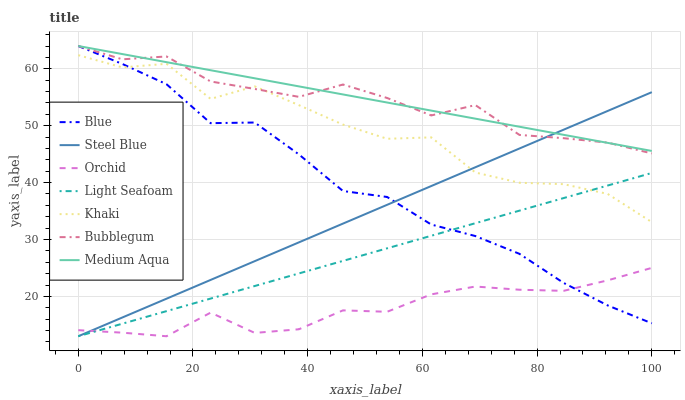Does Orchid have the minimum area under the curve?
Answer yes or no. Yes. Does Medium Aqua have the maximum area under the curve?
Answer yes or no. Yes. Does Khaki have the minimum area under the curve?
Answer yes or no. No. Does Khaki have the maximum area under the curve?
Answer yes or no. No. Is Medium Aqua the smoothest?
Answer yes or no. Yes. Is Khaki the roughest?
Answer yes or no. Yes. Is Steel Blue the smoothest?
Answer yes or no. No. Is Steel Blue the roughest?
Answer yes or no. No. Does Steel Blue have the lowest value?
Answer yes or no. Yes. Does Khaki have the lowest value?
Answer yes or no. No. Does Medium Aqua have the highest value?
Answer yes or no. Yes. Does Khaki have the highest value?
Answer yes or no. No. Is Orchid less than Bubblegum?
Answer yes or no. Yes. Is Medium Aqua greater than Orchid?
Answer yes or no. Yes. Does Medium Aqua intersect Blue?
Answer yes or no. Yes. Is Medium Aqua less than Blue?
Answer yes or no. No. Is Medium Aqua greater than Blue?
Answer yes or no. No. Does Orchid intersect Bubblegum?
Answer yes or no. No. 